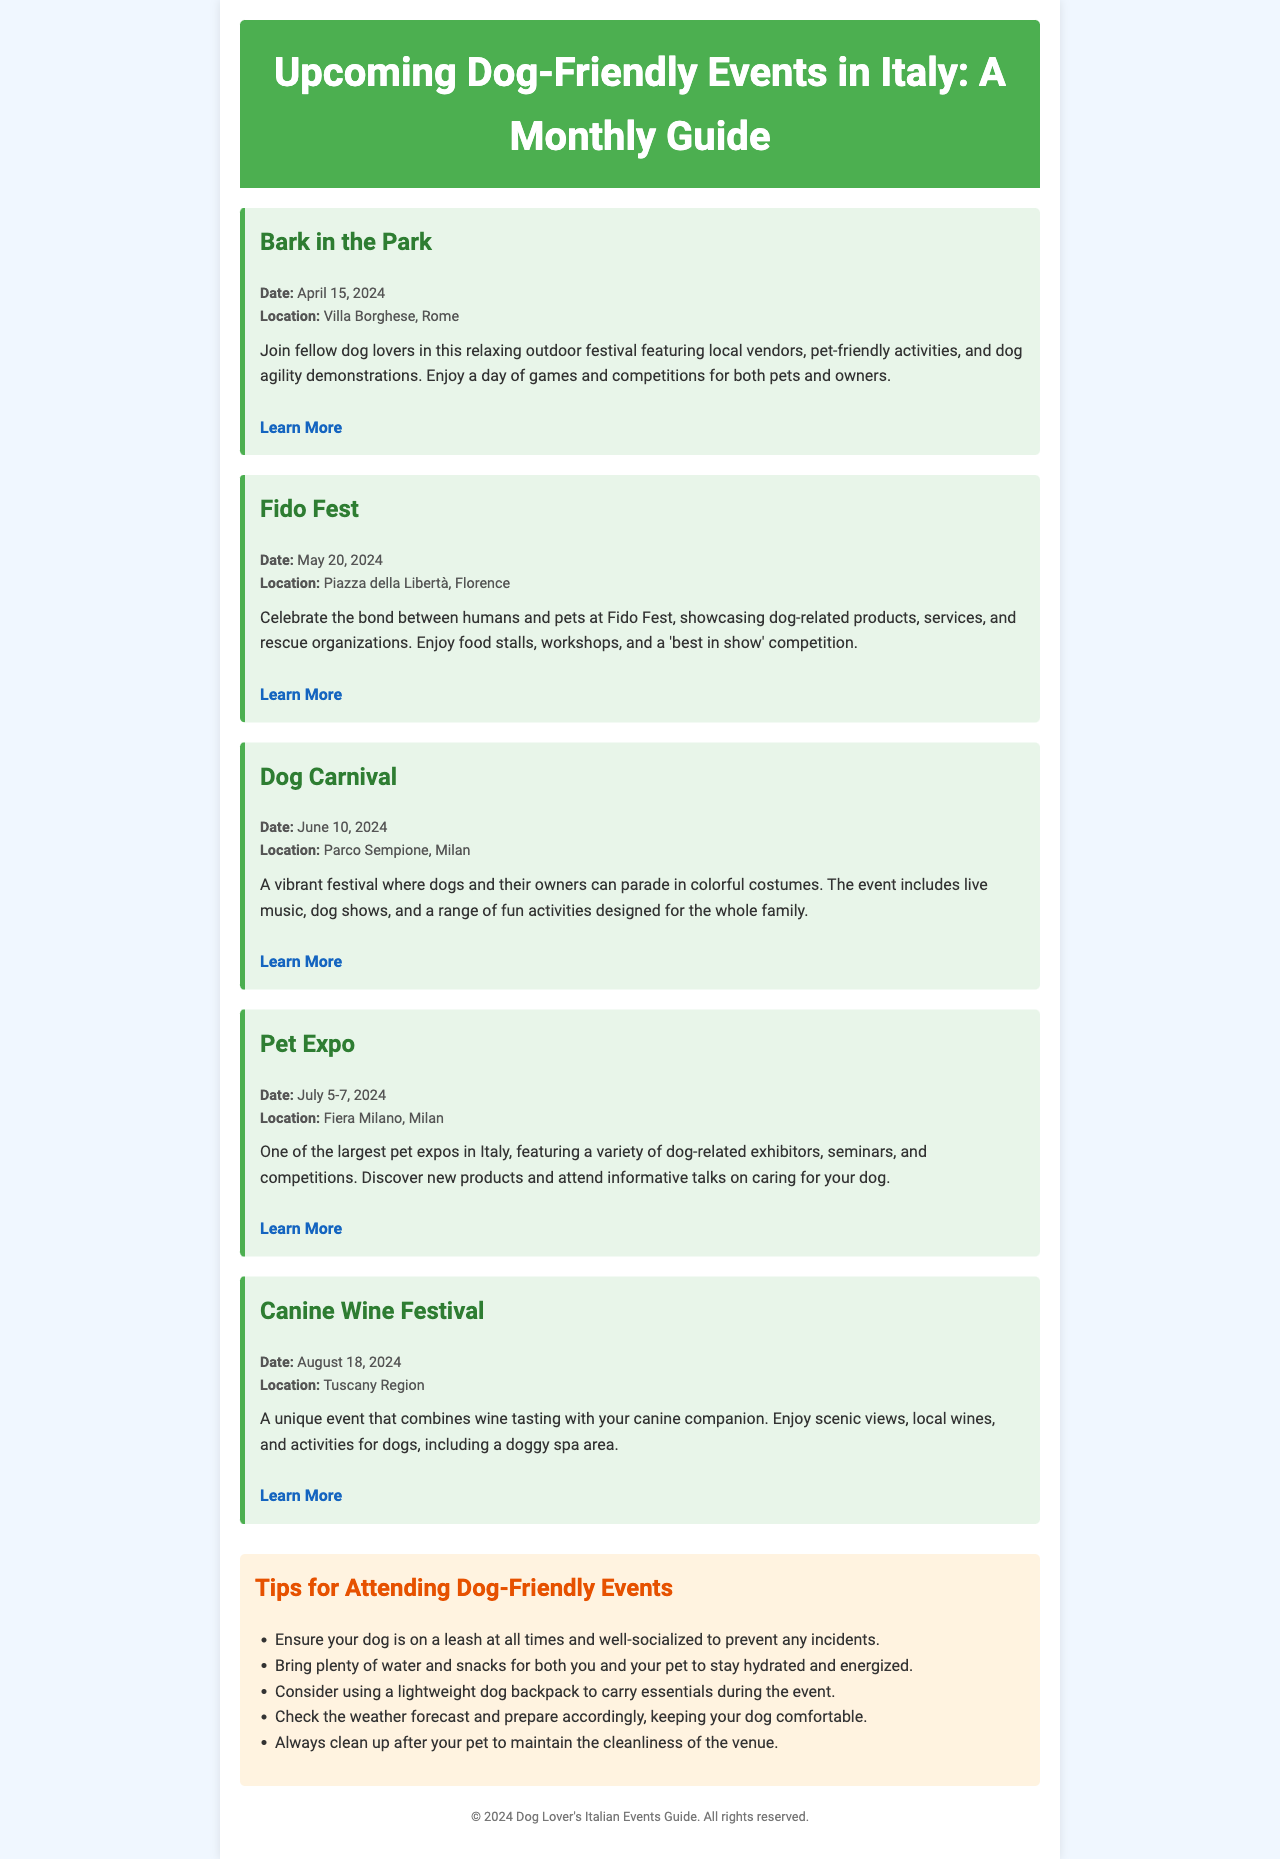What is the title of the first event? The title of the first event is the name given in the document, which is "Bark in the Park."
Answer: Bark in the Park When is the Dog Carnival scheduled? The date for the Dog Carnival is explicitly stated in the document, which is June 10, 2024.
Answer: June 10, 2024 Where will Fido Fest take place? The location of Fido Fest can be found in the event details, which indicate it is at Piazza della Libertà, Florence.
Answer: Piazza della Libertà, Florence How many days does the Pet Expo last? The Pet Expo details mention the duration as July 5-7, 2024, indicating it lasts for 3 days.
Answer: 3 days What activity will be featured at the Canine Wine Festival? The event description for the Canine Wine Festival lists wine tasting as one of its features.
Answer: Wine tasting What is a tip mentioned for attending these events? The document provides tips for attending dog-friendly events, one of which is to ensure your dog is on a leash at all times.
Answer: Dog on a leash What type of document is this? The structure and content suggest it is a newsletter detailing upcoming events.
Answer: Newsletter Which month does Bark in the Park occur? The date provided in the document indicates Bark in the Park is in April.
Answer: April What color is the header background? The document specifies the header background color is green, with a corresponding hex code or name.
Answer: Green 